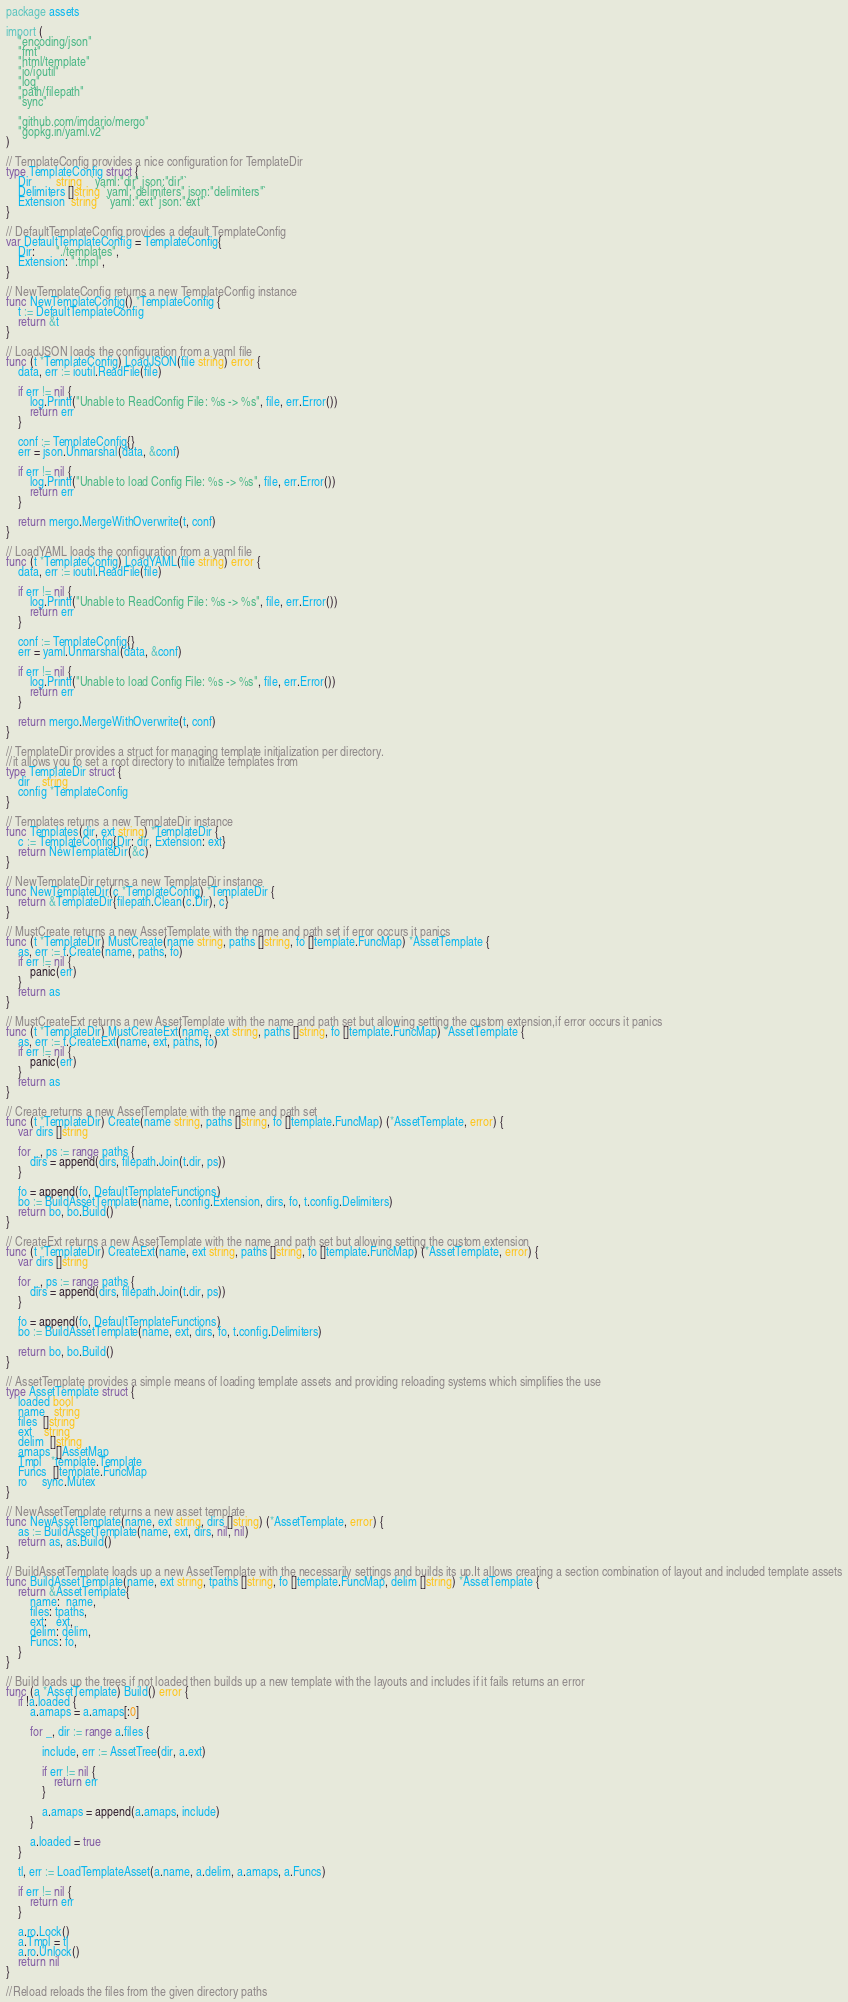Convert code to text. <code><loc_0><loc_0><loc_500><loc_500><_Go_>package assets

import (
	"encoding/json"
	"fmt"
	"html/template"
	"io/ioutil"
	"log"
	"path/filepath"
	"sync"

	"github.com/imdario/mergo"
	"gopkg.in/yaml.v2"
)

// TemplateConfig provides a nice configuration for TemplateDir
type TemplateConfig struct {
	Dir        string   `yaml:"dir" json:"dir"`
	Delimiters []string `yaml:"delimiters" json:"delimiters"`
	Extension  string   `yaml:"ext" json:"ext"`
}

// DefaultTemplateConfig provides a default TemplateConfig
var DefaultTemplateConfig = TemplateConfig{
	Dir:       "./templates",
	Extension: ".tmpl",
}

// NewTemplateConfig returns a new TemplateConfig instance
func NewTemplateConfig() *TemplateConfig {
	t := DefaultTemplateConfig
	return &t
}

// LoadJSON loads the configuration from a yaml file
func (t *TemplateConfig) LoadJSON(file string) error {
	data, err := ioutil.ReadFile(file)

	if err != nil {
		log.Printf("Unable to ReadConfig File: %s -> %s", file, err.Error())
		return err
	}

	conf := TemplateConfig{}
	err = json.Unmarshal(data, &conf)

	if err != nil {
		log.Printf("Unable to load Config File: %s -> %s", file, err.Error())
		return err
	}

	return mergo.MergeWithOverwrite(t, conf)
}

// LoadYAML loads the configuration from a yaml file
func (t *TemplateConfig) LoadYAML(file string) error {
	data, err := ioutil.ReadFile(file)

	if err != nil {
		log.Printf("Unable to ReadConfig File: %s -> %s", file, err.Error())
		return err
	}

	conf := TemplateConfig{}
	err = yaml.Unmarshal(data, &conf)

	if err != nil {
		log.Printf("Unable to load Config File: %s -> %s", file, err.Error())
		return err
	}

	return mergo.MergeWithOverwrite(t, conf)
}

// TemplateDir provides a struct for managing template initialization per directory.
//it allows you to set a root directory to initialize templates from
type TemplateDir struct {
	dir    string
	config *TemplateConfig
}

// Templates returns a new TemplateDir instance
func Templates(dir, ext string) *TemplateDir {
	c := TemplateConfig{Dir: dir, Extension: ext}
	return NewTemplateDir(&c)
}

// NewTemplateDir returns a new TemplateDir instance
func NewTemplateDir(c *TemplateConfig) *TemplateDir {
	return &TemplateDir{filepath.Clean(c.Dir), c}
}

// MustCreate returns a new AssetTemplate with the name and path set if error occurs it panics
func (t *TemplateDir) MustCreate(name string, paths []string, fo []template.FuncMap) *AssetTemplate {
	as, err := t.Create(name, paths, fo)
	if err != nil {
		panic(err)
	}
	return as
}

// MustCreateExt returns a new AssetTemplate with the name and path set but allowing setting the custom extension,if error occurs it panics
func (t *TemplateDir) MustCreateExt(name, ext string, paths []string, fo []template.FuncMap) *AssetTemplate {
	as, err := t.CreateExt(name, ext, paths, fo)
	if err != nil {
		panic(err)
	}
	return as
}

// Create returns a new AssetTemplate with the name and path set
func (t *TemplateDir) Create(name string, paths []string, fo []template.FuncMap) (*AssetTemplate, error) {
	var dirs []string

	for _, ps := range paths {
		dirs = append(dirs, filepath.Join(t.dir, ps))
	}

	fo = append(fo, DefaultTemplateFunctions)
	bo := BuildAssetTemplate(name, t.config.Extension, dirs, fo, t.config.Delimiters)
	return bo, bo.Build()
}

// CreateExt returns a new AssetTemplate with the name and path set but allowing setting the custom extension
func (t *TemplateDir) CreateExt(name, ext string, paths []string, fo []template.FuncMap) (*AssetTemplate, error) {
	var dirs []string

	for _, ps := range paths {
		dirs = append(dirs, filepath.Join(t.dir, ps))
	}

	fo = append(fo, DefaultTemplateFunctions)
	bo := BuildAssetTemplate(name, ext, dirs, fo, t.config.Delimiters)

	return bo, bo.Build()
}

// AssetTemplate provides a simple means of loading template assets and providing reloading systems which simplifies the use
type AssetTemplate struct {
	loaded bool
	name   string
	files  []string
	ext    string
	delim  []string
	amaps  []AssetMap
	Tmpl   *template.Template
	Funcs  []template.FuncMap
	ro     sync.Mutex
}

// NewAssetTemplate returns a new asset template
func NewAssetTemplate(name, ext string, dirs []string) (*AssetTemplate, error) {
	as := BuildAssetTemplate(name, ext, dirs, nil, nil)
	return as, as.Build()
}

// BuildAssetTemplate loads up a new AssetTemplate with the necessarily settings and builds its up.It allows creating a section combination of layout and included template assets
func BuildAssetTemplate(name, ext string, tpaths []string, fo []template.FuncMap, delim []string) *AssetTemplate {
	return &AssetTemplate{
		name:  name,
		files: tpaths,
		ext:   ext,
		delim: delim,
		Funcs: fo,
	}
}

// Build loads up the trees if not loaded then builds up a new template with the layouts and includes if it fails returns an error
func (a *AssetTemplate) Build() error {
	if !a.loaded {
		a.amaps = a.amaps[:0]

		for _, dir := range a.files {

			include, err := AssetTree(dir, a.ext)

			if err != nil {
				return err
			}

			a.amaps = append(a.amaps, include)
		}

		a.loaded = true
	}

	tl, err := LoadTemplateAsset(a.name, a.delim, a.amaps, a.Funcs)

	if err != nil {
		return err
	}

	a.ro.Lock()
	a.Tmpl = tl
	a.ro.Unlock()
	return nil
}

//Reload reloads the files from the given directory paths</code> 